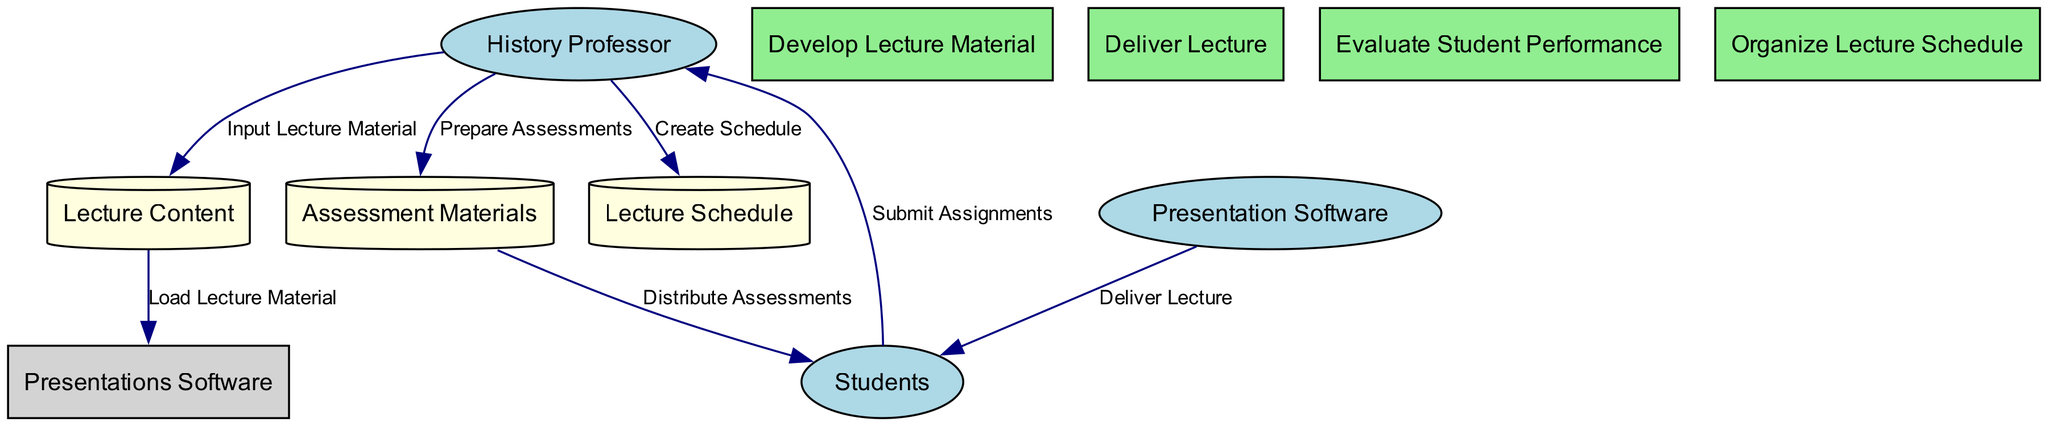What is the total number of external entities in the diagram? The diagram includes external entities: History Professor, Presentation Software, and Students. Counting these entities gives a total of three external entities.
Answer: 3 What type of data store is included in the diagram? The data store in the diagram includes Lecture Content, Assessment Materials, and Lecture Schedule. Each of these is classified as a Data Store, which typically involves organizing historical data.
Answer: Data Store Who is responsible for preparing assessments? The History Professor is designated as the entity responsible for preparing assessments, as indicated by the data flow labeled "Prepare Assessments" that connects them to the Assessment Materials.
Answer: History Professor Which process is responsible for delivering the lecture? The process named "Deliver Lecture" is responsible for this function, as it directly connects the Presentation Software to the Students, indicating the active delivery of the lecture content.
Answer: Deliver Lecture How many data flows originate from the History Professor? The History Professor has four data flows originating from them: "Input Lecture Material," "Prepare Assessments," "Create Schedule," and a connection that leads to the "Deliver Lecture" process. Counting these flows results in four.
Answer: 4 What is the purpose of the "Organize Lecture Schedule" process? The "Organize Lecture Schedule" process is designed to plan and arrange the timeline for the entire lecture series, coordinating when each lecture will take place.
Answer: Plan and arrange timeline Which external entity receives assessments? The Students are indicated as the external entity that receives assessments. This is shown via the data flow labeled "Distribute Assessments," which leads from Assessment Materials to Students.
Answer: Students What is the role of the "Lecture Content" data store in the diagram? The Lecture Content data store holds curated historical materials and is essential for loading lecture material into Presentation Software, enabling the actual delivery of lectures to Students.
Answer: Curated historical materials Which process do students interact with after the lecture? After the lecture, students interact with the "Evaluate Student Performance" process. This process assesses them based on the submissions, such as exams and quizzes they completed after the lecture.
Answer: Evaluate Student Performance 